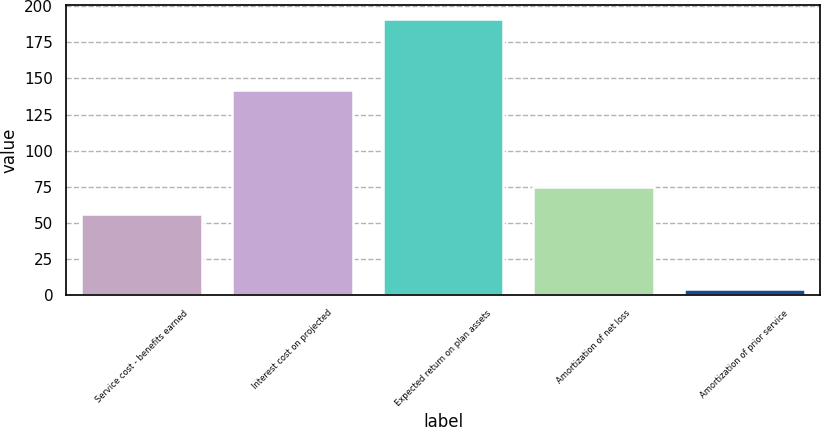Convert chart. <chart><loc_0><loc_0><loc_500><loc_500><bar_chart><fcel>Service cost - benefits earned<fcel>Interest cost on projected<fcel>Expected return on plan assets<fcel>Amortization of net loss<fcel>Amortization of prior service<nl><fcel>56<fcel>142<fcel>191<fcel>74.7<fcel>4<nl></chart> 